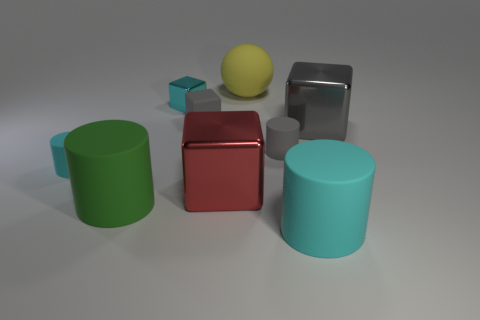Subtract 1 cylinders. How many cylinders are left? 3 Add 1 yellow matte things. How many objects exist? 10 Subtract all cylinders. How many objects are left? 5 Add 4 tiny cyan metal objects. How many tiny cyan metal objects are left? 5 Add 6 big matte objects. How many big matte objects exist? 9 Subtract 0 green balls. How many objects are left? 9 Subtract all tiny cyan rubber cylinders. Subtract all blocks. How many objects are left? 4 